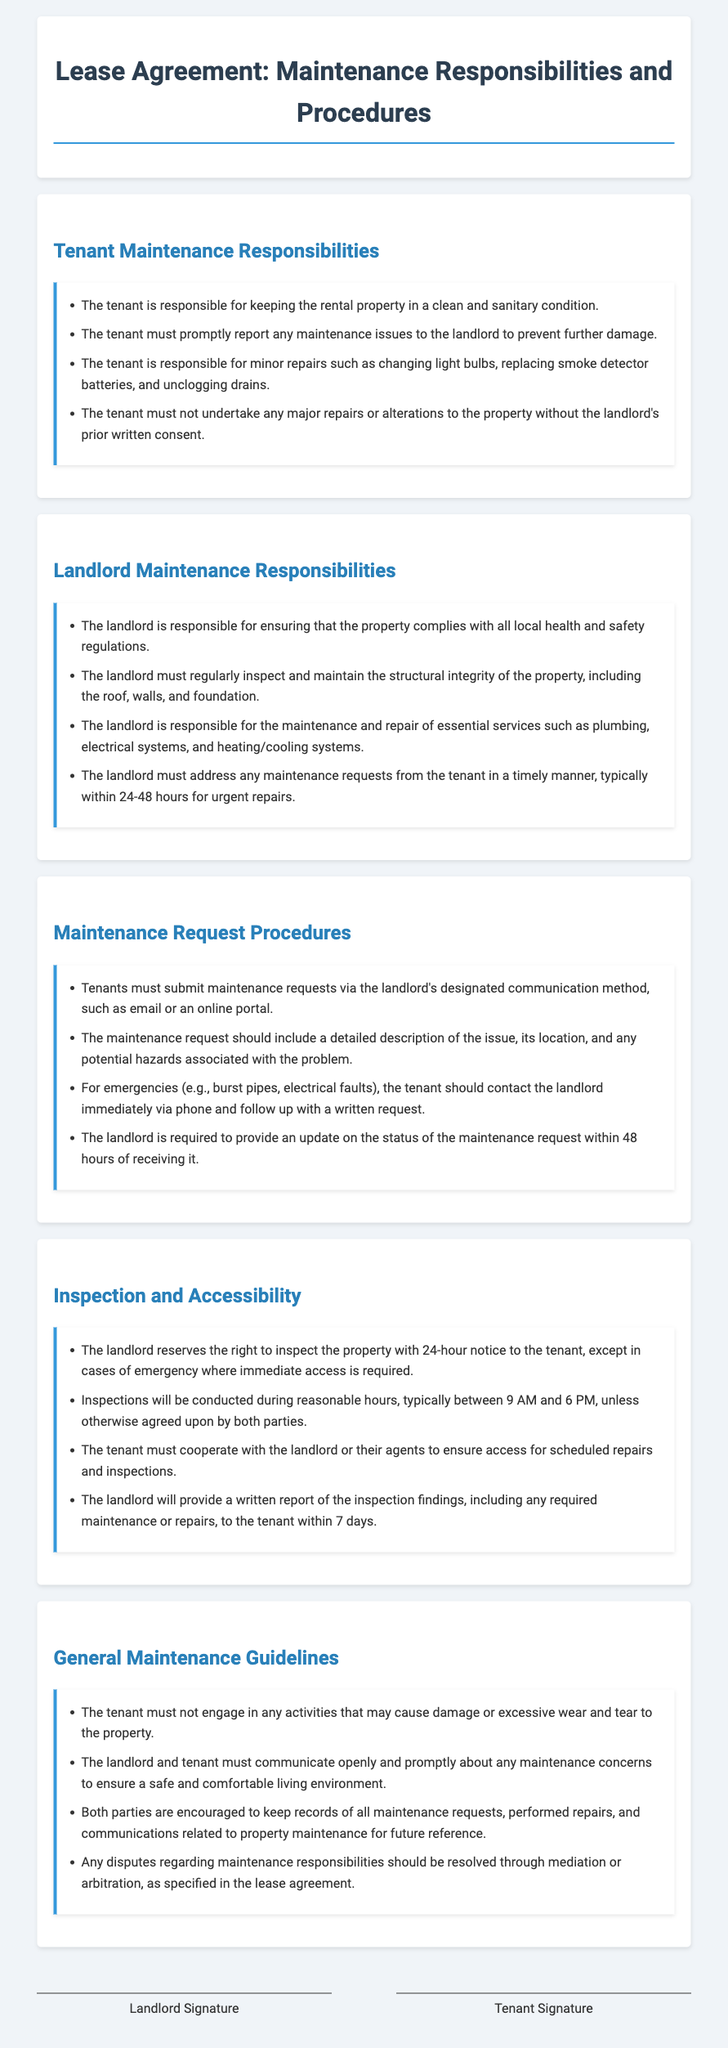what are the tenant's responsibilities? The tenant's responsibilities are outlined in the section titled "Tenant Maintenance Responsibilities."
Answer: keeping the rental property in a clean and sanitary condition what must the landlord maintain? The landlord's maintenance responsibilities are listed in the section titled "Landlord Maintenance Responsibilities."
Answer: essential services such as plumbing, electrical systems, and heating/cooling systems how should maintenance requests be submitted? The procedures for submitting maintenance requests are found in the "Maintenance Request Procedures" section.
Answer: via the landlord's designated communication method, such as email or an online portal what notice is required for inspections? The notice required for inspections is mentioned in the "Inspection and Accessibility" section.
Answer: 24-hour notice what is the time frame for the landlord to update on a maintenance request? The time frame for the landlord to provide an update is specified in the "Maintenance Request Procedures."
Answer: within 48 hours who bears the responsibility for minor repairs? This information is located in the section "Tenant Maintenance Responsibilities."
Answer: tenant what rights does the landlord reserve for inspections? This topic is discussed in the "Inspection and Accessibility" section of the document.
Answer: right to inspect the property what should be included in a maintenance request? The necessary information for a maintenance request is provided in the "Maintenance Request Procedures" section.
Answer: a detailed description of the issue, its location, and any potential hazards how should disputes regarding maintenance be resolved? The resolution of disputes is referenced in the "General Maintenance Guidelines."
Answer: through mediation or arbitration 